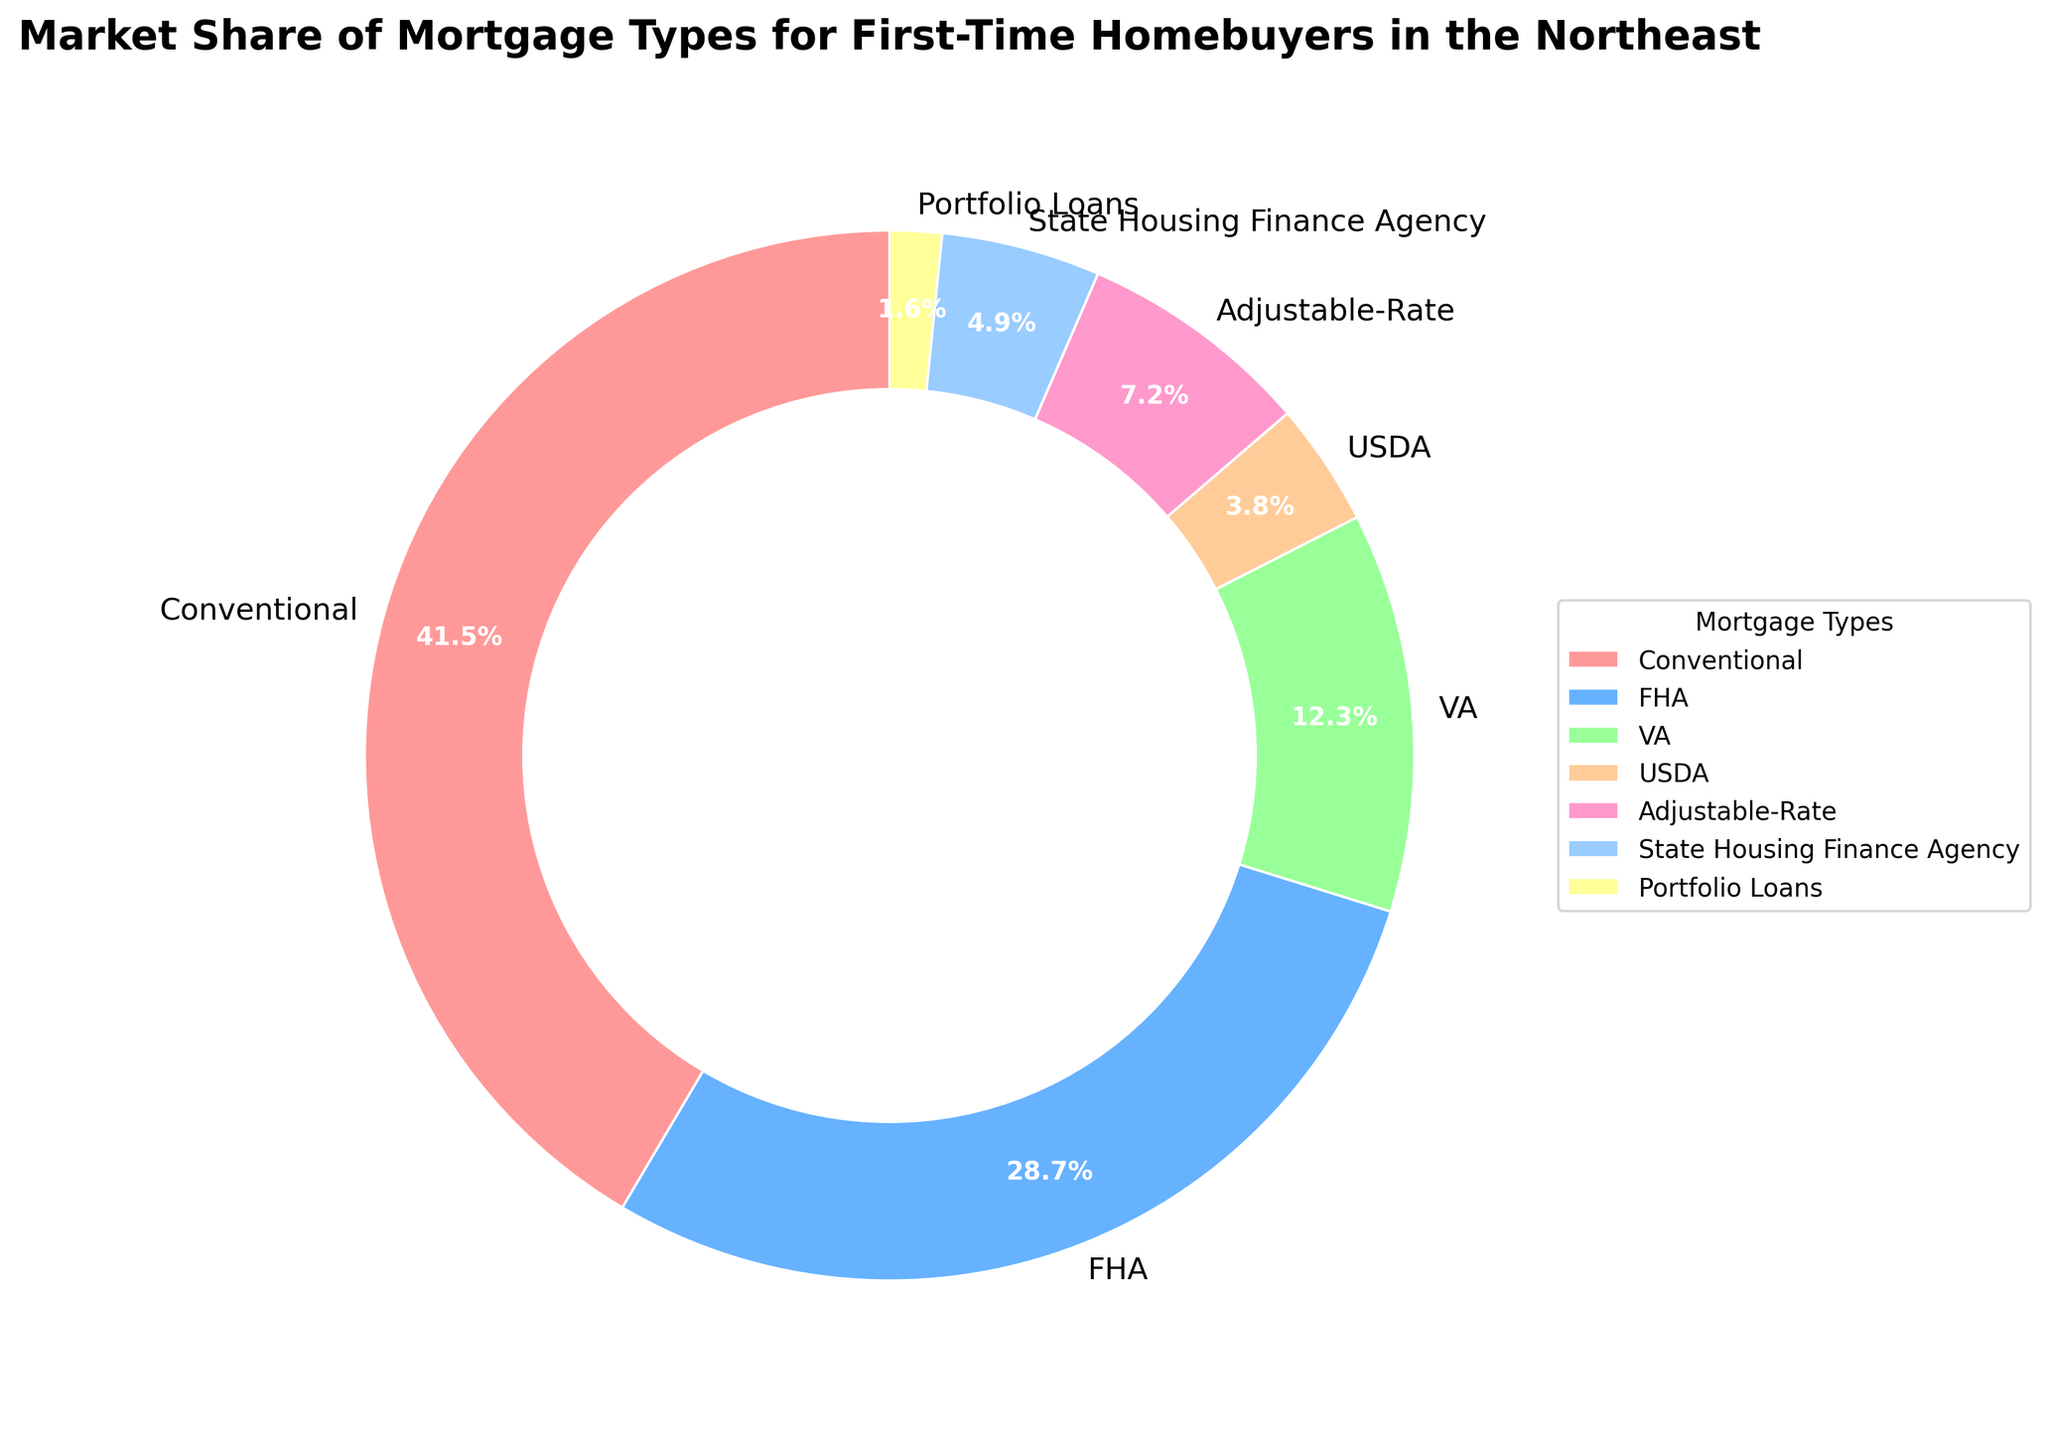Which mortgage type has the largest market share? The largest wedge in the pie chart represents the mortgage type with the largest market share.
Answer: Conventional What is the combined market share of FHA and VA loans? To find the combined market share, add the percentages for FHA and VA loans: 28.7% and 12.3%.
Answer: 41.0% Which mortgage type has the smallest market share? The smallest wedge in the pie chart represents the mortgage type with the smallest market share.
Answer: Portfolio Loans How much larger is the market share of Conventional mortgages compared to Adjustable-Rate mortgages? Subtract the percentage of Adjustable-Rate mortgages from the percentage of Conventional mortgages: 41.5% - 7.2%.
Answer: 34.3% What is the average market share of USDA and State Housing Finance Agency loans? Add the percentages of USDA and State Housing Finance Agency loans and then divide by 2: (3.8% + 4.9%) / 2.
Answer: 4.35% Which mortgage type has a market share of over 25% but less than 50%? Look for wedges representing mortgage types within the given range.
Answer: Conventional and FHA Is the market share of FHA loans more than twice that of USDA loans? Compare 28.7% (FHA) to twice the percentage of USDA loans (2 * 3.8% = 7.6%).
Answer: Yes What color represents the Portfolio Loans wedge? Observe the color of the wedge labeled Portfolio Loans in the pie chart.
Answer: Yellow How many mortgage types have a market share of less than 10%? Count the wedges representing mortgage types with a market share below 10%.
Answer: Four What's the difference in market share between the top two mortgage types? Subtract the second-largest market share (FHA, 28.7%) from the largest market share (Conventional, 41.5%).
Answer: 12.8% 